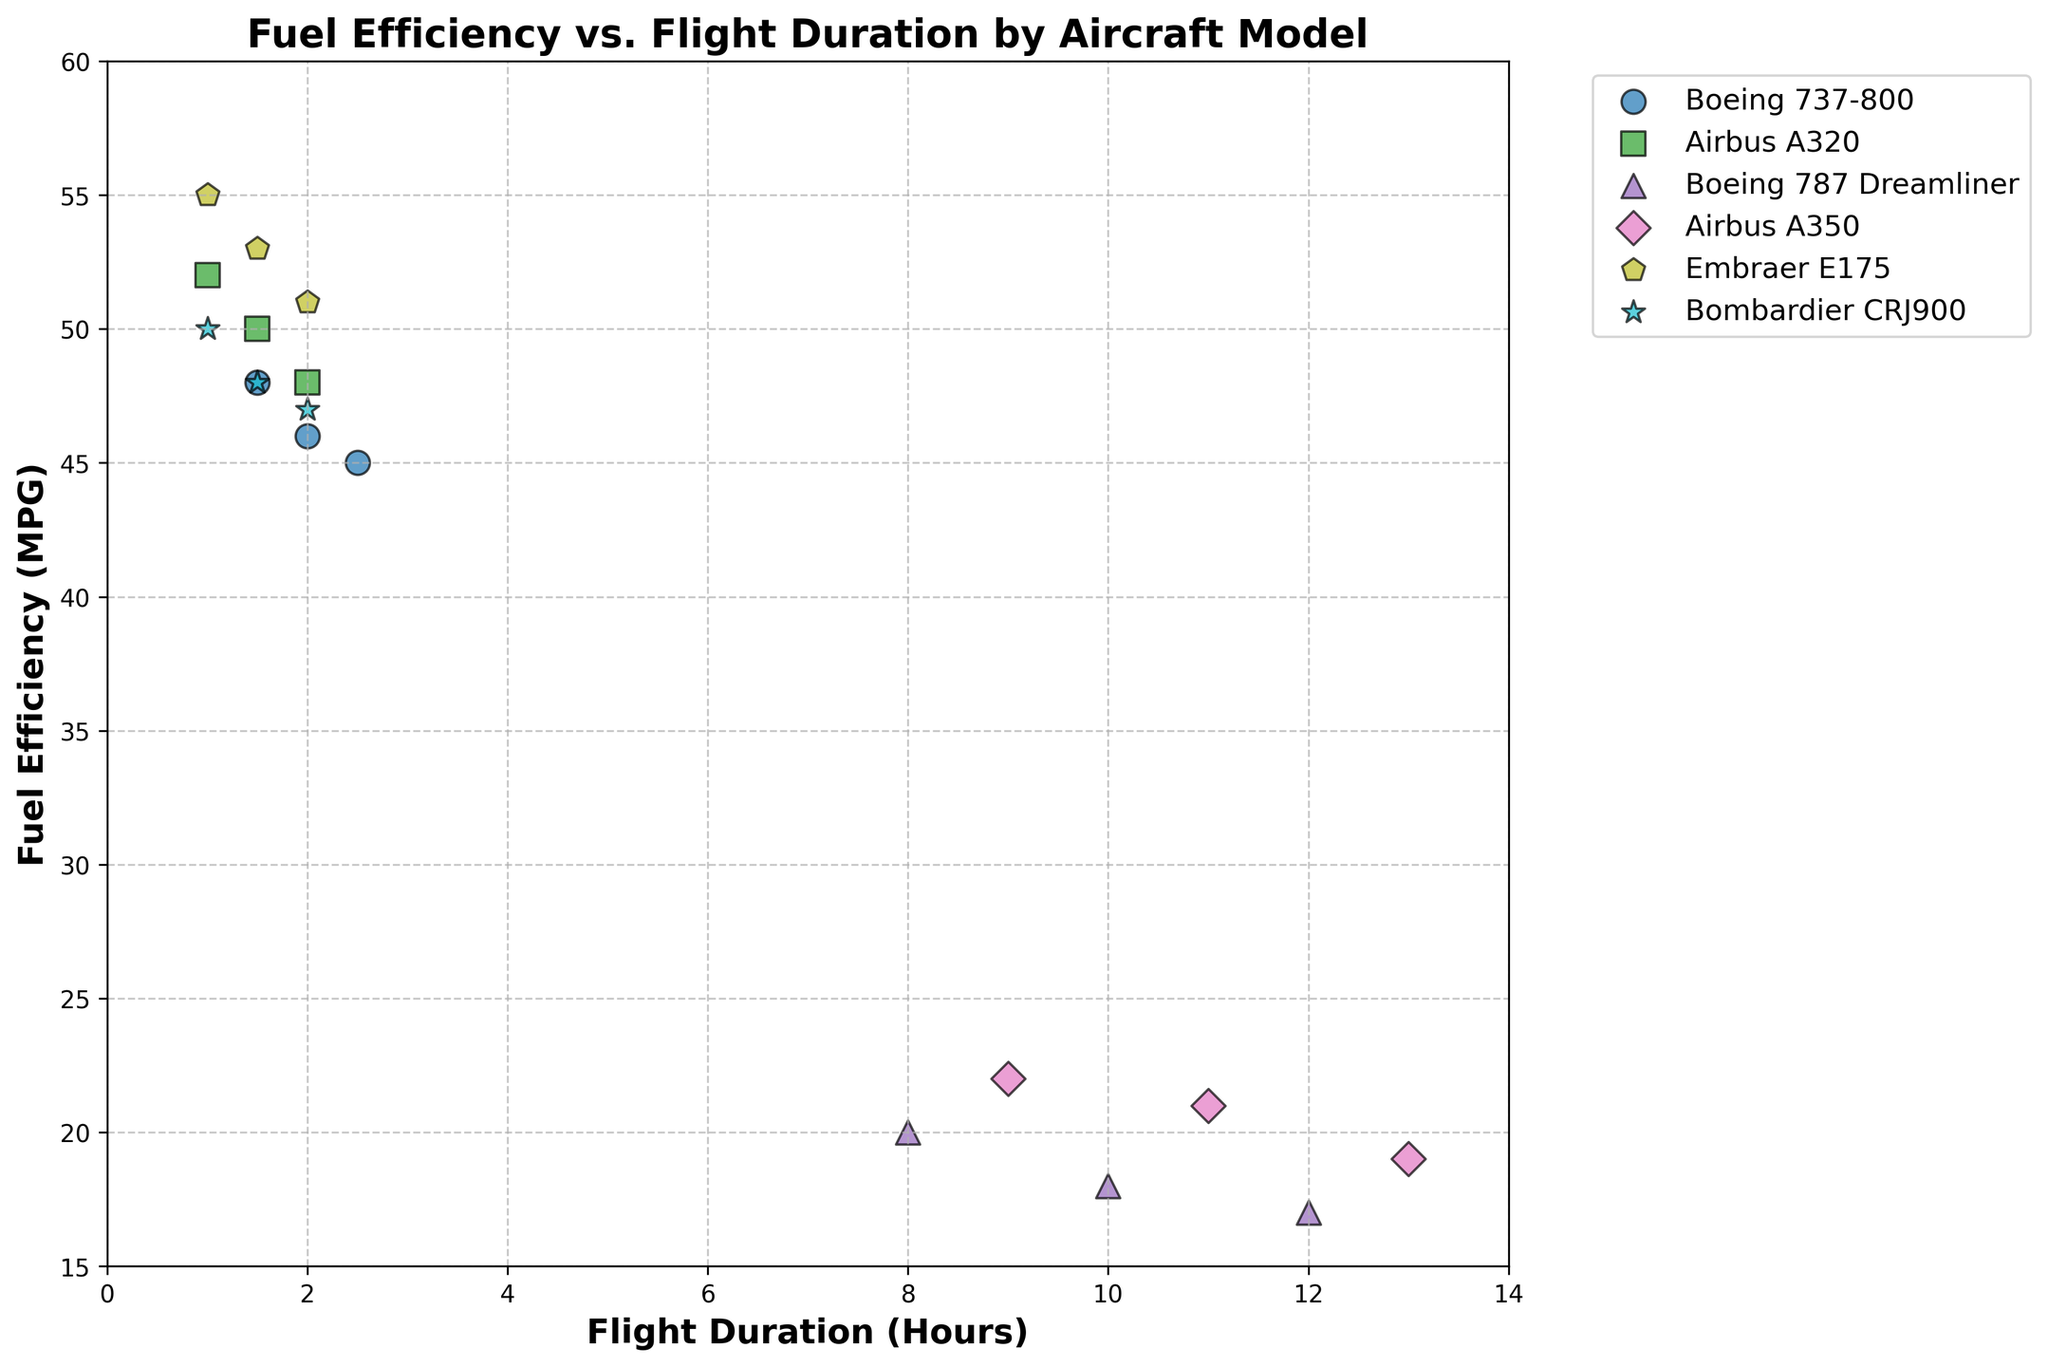What's the title of the figure? The title is usually placed at the top of the figure, centered and prominently displayed. The title in this case is "Fuel Efficiency vs. Flight Duration by Aircraft Model".
Answer: Fuel Efficiency vs. Flight Duration by Aircraft Model How many different aircraft models are represented in the figure? The legend shows all the distinct aircraft models present in the scatter plot. By counting them, we see: Boeing 737-800, Airbus A320, Boeing 787 Dreamliner, Airbus A350, Embraer E175, and Bombardier CRJ900.
Answer: 6 Which aircraft model has the highest fuel efficiency for a 1-hour flight? Look for the data points at the 1-hour mark on the x-axis, then find the highest y-value (fuel efficiency). For 1-hour flights, Embraer E175 has a fuel efficiency of 55 MPG, which is the highest.
Answer: Embraer E175 At a flight duration of 2.0 hours, which aircraft model has the lowest fuel efficiency? Locate the 2.0-hour mark on the x-axis, then compare the y-values (fuel efficiency) of all data points with this x-value. The Boeing 737-800 has the lowest fuel efficiency at 2.0 hours with 45 MPG.
Answer: Boeing 737-800 How does the fuel efficiency trend differ between short-haul (1-2 hours) and long-haul (8-13 hours) flights? Compare the trend in data points for short-haul flights (1-2 hours) which generally decrease slightly but remain high, versus long-haul flights (8-13 hours) which decrease more sharply in fuel efficiency.
Answer: Short-haul flights have a slight decrease, long-haul flights decrease sharply Which aircraft model shows the greatest decrease in fuel efficiency with increased flight duration? Identify the slopes of the scatter plot lines for each model. The Boeing 787 Dreamliner exhibits the most significant decline from 20 MPG at 8 hours to 17 MPG at 12 hours.
Answer: Boeing 787 Dreamliner What is the average fuel efficiency for the Airbus A350 over all its recorded flights? Extract the MPG values for the Airbus A350 (22, 21, 19), then calculate the average: (22 + 21 + 19) / 3 = 62 / 3.
Answer: 20.67 MPG For the Boeing 737-800, how does fuel efficiency change between 1.5 hours and 2.5 hours? Find the fuel efficiency at 1.5 hours (48 MPG) and 2.5 hours (45 MPG). The change is 48 - 45 = 3 MPG.
Answer: Decreases by 3 MPG Compare the fuel efficiency at 10 hours for the Boeing 787 Dreamliner and the Airbus A350. Which one is more efficient? Look at the 10-hour mark on the x-axis and compare the corresponding y-values. Boeing 787 Dreamliner is at 18 MPG, while Airbus A350 is not specifically represented at 10 hours but is lower than 22 MPG at nearby times.
Answer: Boeing 787 Dreamliner (answer as closest available) 